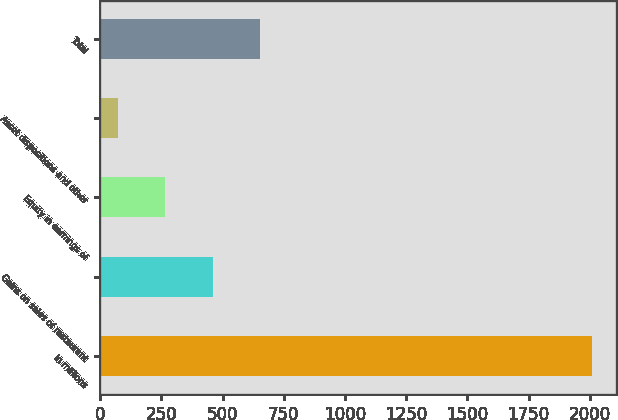<chart> <loc_0><loc_0><loc_500><loc_500><bar_chart><fcel>In millions<fcel>Gains on sales of restaurant<fcel>Equity in earnings of<fcel>Asset dispositions and other<fcel>Total<nl><fcel>2008<fcel>459.2<fcel>265.6<fcel>72<fcel>652.8<nl></chart> 